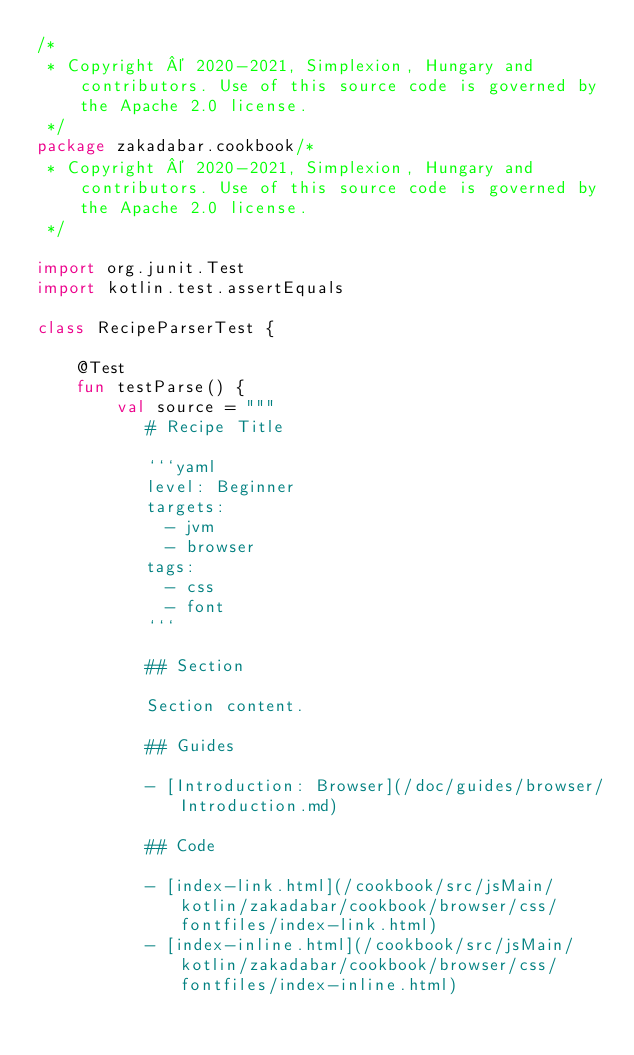Convert code to text. <code><loc_0><loc_0><loc_500><loc_500><_Kotlin_>/*
 * Copyright © 2020-2021, Simplexion, Hungary and contributors. Use of this source code is governed by the Apache 2.0 license.
 */
package zakadabar.cookbook/*
 * Copyright © 2020-2021, Simplexion, Hungary and contributors. Use of this source code is governed by the Apache 2.0 license.
 */

import org.junit.Test
import kotlin.test.assertEquals

class RecipeParserTest {

    @Test
    fun testParse() {
        val source = """
           # Recipe Title

           ```yaml
           level: Beginner
           targets:
             - jvm
             - browser
           tags:
             - css
             - font
           ```

           ## Section

           Section content.

           ## Guides

           - [Introduction: Browser](/doc/guides/browser/Introduction.md)

           ## Code

           - [index-link.html](/cookbook/src/jsMain/kotlin/zakadabar/cookbook/browser/css/fontfiles/index-link.html)
           - [index-inline.html](/cookbook/src/jsMain/kotlin/zakadabar/cookbook/browser/css/fontfiles/index-inline.html)</code> 